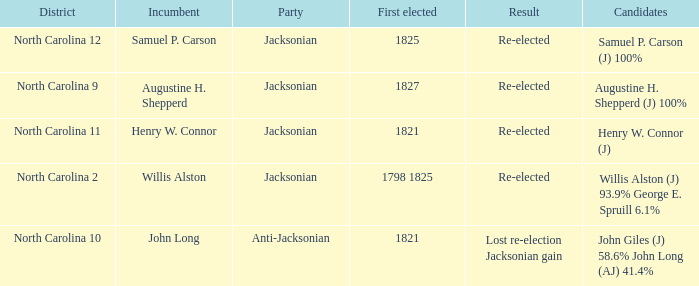Name the result for first elected being 1798 1825 Re-elected. 